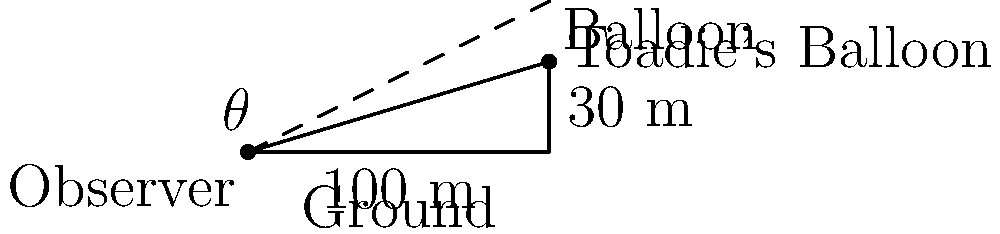At the annual Neighbours fan convention, you spot Toadie Rebecchi's hot air balloon in the distance. Standing on level ground, you measure the distance to a point directly beneath the balloon to be 100 meters. The balloon is hovering at a height of 30 meters. What is the angle of elevation ($\theta$) from your position to Toadie's balloon? Let's approach this step-by-step using trigonometry:

1) We have a right-angled triangle where:
   - The adjacent side (ground distance) is 100 meters
   - The opposite side (balloon height) is 30 meters
   - We need to find the angle $\theta$

2) In a right-angled triangle, $\tan \theta = \frac{\text{opposite}}{\text{adjacent}}$

3) Substituting our values:

   $\tan \theta = \frac{30}{100} = 0.3$

4) To find $\theta$, we need to use the inverse tangent (arctan or $\tan^{-1}$):

   $\theta = \tan^{-1}(0.3)$

5) Using a calculator or trigonometric tables:

   $\theta \approx 16.70^\circ$

6) Rounding to the nearest degree:

   $\theta \approx 17^\circ$

Therefore, the angle of elevation to spot Toadie's hot air balloon is approximately 17 degrees.
Answer: $17^\circ$ 